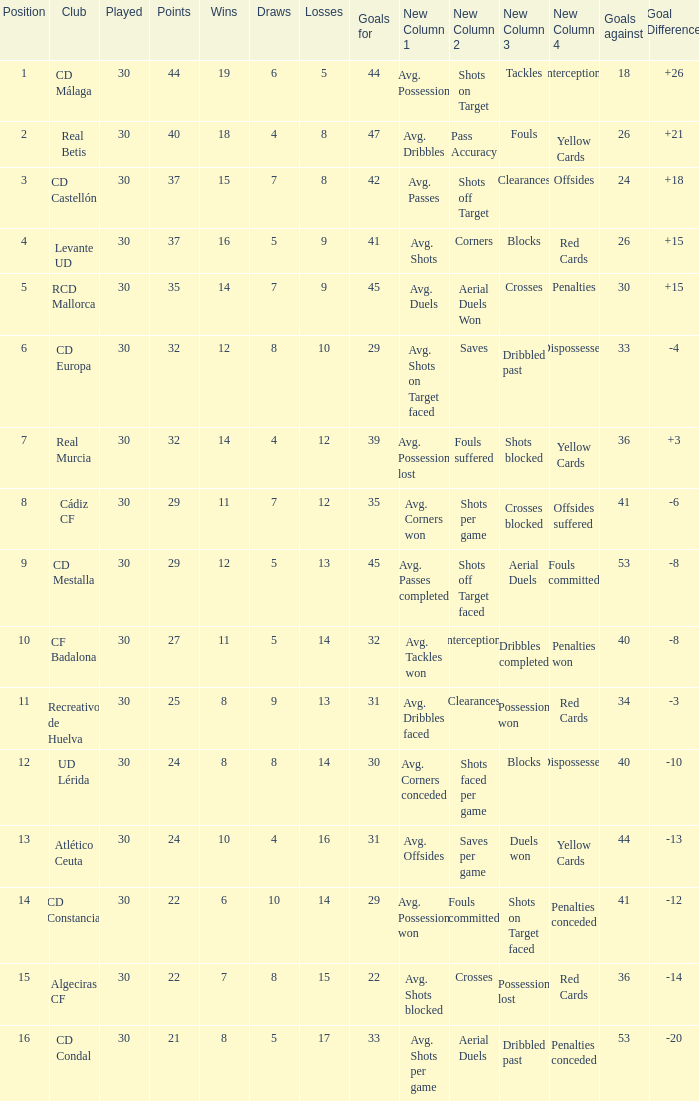What is the number of draws when played is smaller than 30? 0.0. 